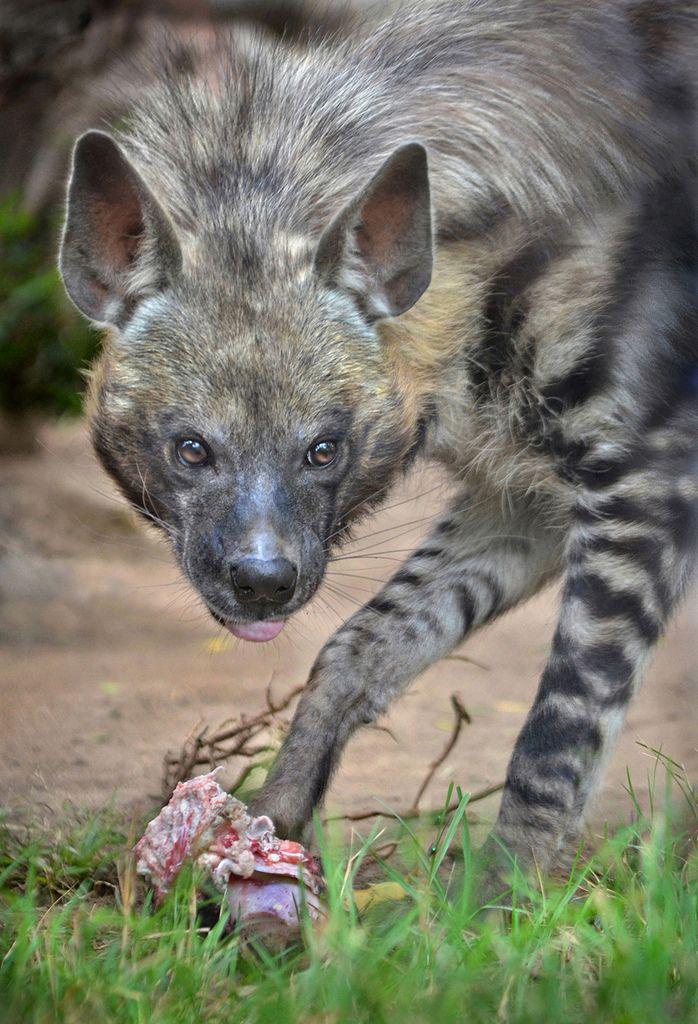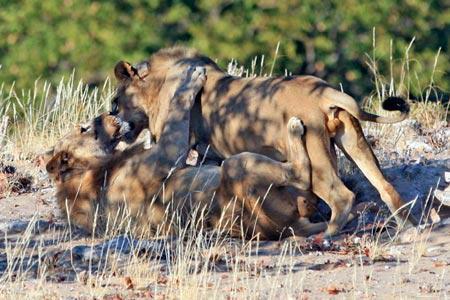The first image is the image on the left, the second image is the image on the right. For the images shown, is this caption "Each picture has exactly one hyena." true? Answer yes or no. No. The first image is the image on the left, the second image is the image on the right. Given the left and right images, does the statement "There is at most two hyenas." hold true? Answer yes or no. No. 